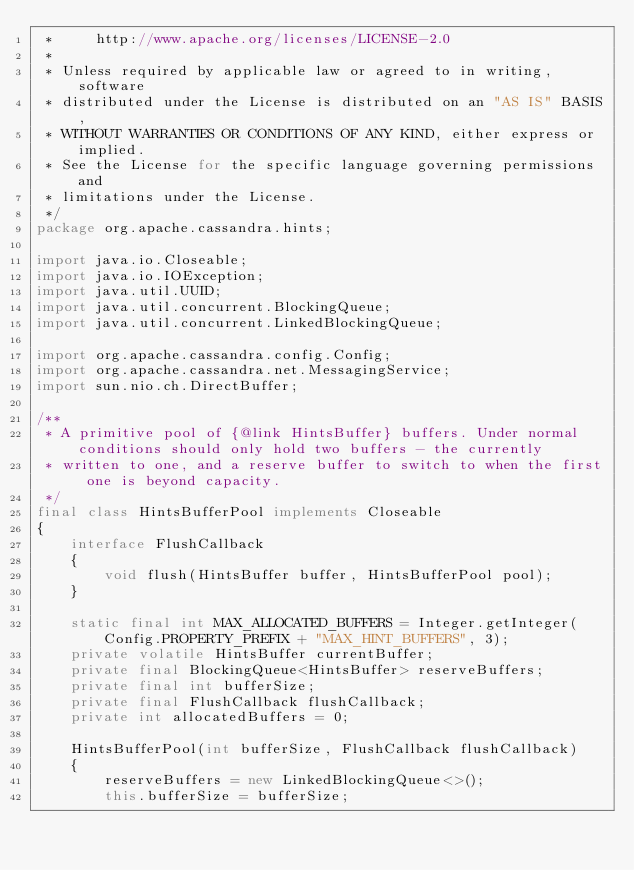Convert code to text. <code><loc_0><loc_0><loc_500><loc_500><_Java_> *     http://www.apache.org/licenses/LICENSE-2.0
 *
 * Unless required by applicable law or agreed to in writing, software
 * distributed under the License is distributed on an "AS IS" BASIS,
 * WITHOUT WARRANTIES OR CONDITIONS OF ANY KIND, either express or implied.
 * See the License for the specific language governing permissions and
 * limitations under the License.
 */
package org.apache.cassandra.hints;

import java.io.Closeable;
import java.io.IOException;
import java.util.UUID;
import java.util.concurrent.BlockingQueue;
import java.util.concurrent.LinkedBlockingQueue;

import org.apache.cassandra.config.Config;
import org.apache.cassandra.net.MessagingService;
import sun.nio.ch.DirectBuffer;

/**
 * A primitive pool of {@link HintsBuffer} buffers. Under normal conditions should only hold two buffers - the currently
 * written to one, and a reserve buffer to switch to when the first one is beyond capacity.
 */
final class HintsBufferPool implements Closeable
{
    interface FlushCallback
    {
        void flush(HintsBuffer buffer, HintsBufferPool pool);
    }

    static final int MAX_ALLOCATED_BUFFERS = Integer.getInteger(Config.PROPERTY_PREFIX + "MAX_HINT_BUFFERS", 3);
    private volatile HintsBuffer currentBuffer;
    private final BlockingQueue<HintsBuffer> reserveBuffers;
    private final int bufferSize;
    private final FlushCallback flushCallback;
    private int allocatedBuffers = 0;

    HintsBufferPool(int bufferSize, FlushCallback flushCallback)
    {
        reserveBuffers = new LinkedBlockingQueue<>();
        this.bufferSize = bufferSize;</code> 